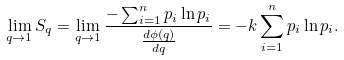Convert formula to latex. <formula><loc_0><loc_0><loc_500><loc_500>\lim _ { q \to 1 } S _ { q } = \lim _ { q \to 1 } \frac { - \sum _ { i = 1 } ^ { n } p _ { i } \ln p _ { i } } { \frac { d \phi ( q ) } { d q } } = - k \sum _ { i = 1 } ^ { n } p _ { i } \ln p _ { i } .</formula> 